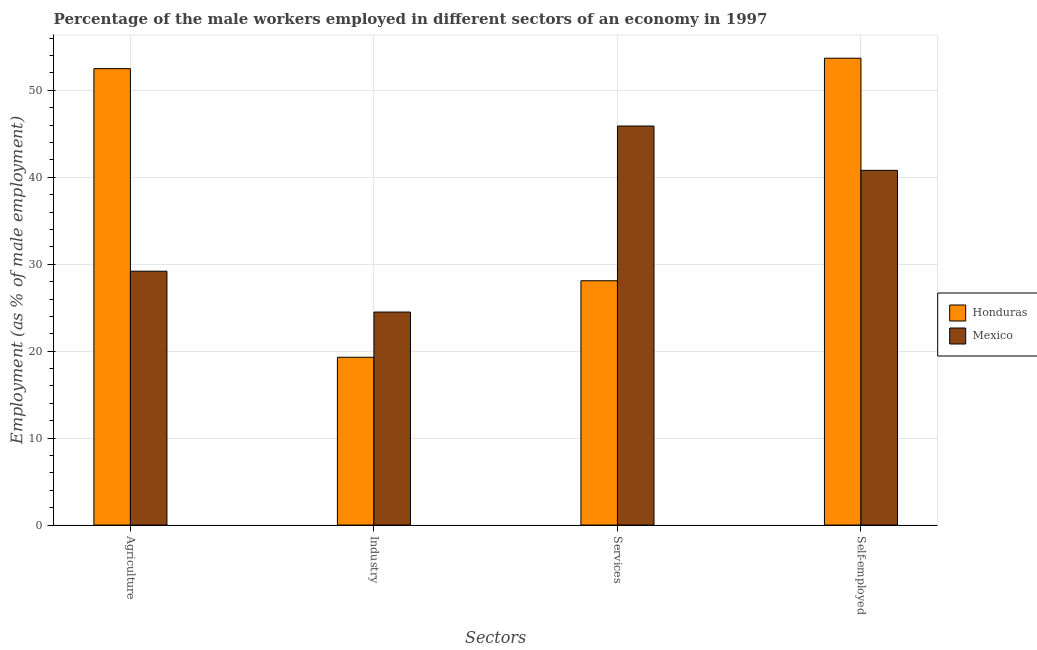How many bars are there on the 4th tick from the left?
Your answer should be very brief. 2. How many bars are there on the 1st tick from the right?
Provide a short and direct response. 2. What is the label of the 4th group of bars from the left?
Offer a very short reply. Self-employed. What is the percentage of male workers in agriculture in Mexico?
Provide a short and direct response. 29.2. Across all countries, what is the maximum percentage of male workers in services?
Provide a short and direct response. 45.9. Across all countries, what is the minimum percentage of male workers in agriculture?
Your answer should be compact. 29.2. In which country was the percentage of male workers in industry maximum?
Provide a succinct answer. Mexico. In which country was the percentage of male workers in industry minimum?
Offer a very short reply. Honduras. What is the total percentage of self employed male workers in the graph?
Give a very brief answer. 94.5. What is the difference between the percentage of male workers in agriculture in Mexico and that in Honduras?
Ensure brevity in your answer.  -23.3. What is the difference between the percentage of male workers in industry in Mexico and the percentage of self employed male workers in Honduras?
Provide a short and direct response. -29.2. What is the average percentage of male workers in services per country?
Your answer should be compact. 37. What is the difference between the percentage of male workers in agriculture and percentage of male workers in industry in Honduras?
Give a very brief answer. 33.2. In how many countries, is the percentage of male workers in services greater than 6 %?
Ensure brevity in your answer.  2. What is the ratio of the percentage of male workers in industry in Mexico to that in Honduras?
Keep it short and to the point. 1.27. Is the percentage of male workers in services in Honduras less than that in Mexico?
Give a very brief answer. Yes. What is the difference between the highest and the second highest percentage of male workers in services?
Your answer should be compact. 17.8. What is the difference between the highest and the lowest percentage of male workers in services?
Ensure brevity in your answer.  17.8. In how many countries, is the percentage of male workers in industry greater than the average percentage of male workers in industry taken over all countries?
Provide a succinct answer. 1. Is the sum of the percentage of male workers in services in Mexico and Honduras greater than the maximum percentage of male workers in agriculture across all countries?
Provide a succinct answer. Yes. What does the 2nd bar from the left in Services represents?
Offer a very short reply. Mexico. What does the 2nd bar from the right in Agriculture represents?
Provide a short and direct response. Honduras. How many bars are there?
Make the answer very short. 8. Does the graph contain any zero values?
Provide a short and direct response. No. Where does the legend appear in the graph?
Your answer should be very brief. Center right. What is the title of the graph?
Make the answer very short. Percentage of the male workers employed in different sectors of an economy in 1997. Does "Cambodia" appear as one of the legend labels in the graph?
Make the answer very short. No. What is the label or title of the X-axis?
Your answer should be very brief. Sectors. What is the label or title of the Y-axis?
Ensure brevity in your answer.  Employment (as % of male employment). What is the Employment (as % of male employment) in Honduras in Agriculture?
Your answer should be very brief. 52.5. What is the Employment (as % of male employment) of Mexico in Agriculture?
Give a very brief answer. 29.2. What is the Employment (as % of male employment) of Honduras in Industry?
Your answer should be compact. 19.3. What is the Employment (as % of male employment) of Honduras in Services?
Offer a terse response. 28.1. What is the Employment (as % of male employment) of Mexico in Services?
Give a very brief answer. 45.9. What is the Employment (as % of male employment) in Honduras in Self-employed?
Offer a very short reply. 53.7. What is the Employment (as % of male employment) in Mexico in Self-employed?
Offer a terse response. 40.8. Across all Sectors, what is the maximum Employment (as % of male employment) in Honduras?
Offer a very short reply. 53.7. Across all Sectors, what is the maximum Employment (as % of male employment) in Mexico?
Keep it short and to the point. 45.9. Across all Sectors, what is the minimum Employment (as % of male employment) in Honduras?
Provide a succinct answer. 19.3. What is the total Employment (as % of male employment) of Honduras in the graph?
Your answer should be very brief. 153.6. What is the total Employment (as % of male employment) in Mexico in the graph?
Your answer should be compact. 140.4. What is the difference between the Employment (as % of male employment) in Honduras in Agriculture and that in Industry?
Provide a succinct answer. 33.2. What is the difference between the Employment (as % of male employment) of Honduras in Agriculture and that in Services?
Ensure brevity in your answer.  24.4. What is the difference between the Employment (as % of male employment) of Mexico in Agriculture and that in Services?
Your answer should be very brief. -16.7. What is the difference between the Employment (as % of male employment) of Honduras in Agriculture and that in Self-employed?
Offer a terse response. -1.2. What is the difference between the Employment (as % of male employment) of Mexico in Agriculture and that in Self-employed?
Offer a terse response. -11.6. What is the difference between the Employment (as % of male employment) in Honduras in Industry and that in Services?
Your answer should be very brief. -8.8. What is the difference between the Employment (as % of male employment) of Mexico in Industry and that in Services?
Make the answer very short. -21.4. What is the difference between the Employment (as % of male employment) of Honduras in Industry and that in Self-employed?
Provide a short and direct response. -34.4. What is the difference between the Employment (as % of male employment) in Mexico in Industry and that in Self-employed?
Your answer should be very brief. -16.3. What is the difference between the Employment (as % of male employment) in Honduras in Services and that in Self-employed?
Give a very brief answer. -25.6. What is the difference between the Employment (as % of male employment) in Honduras in Agriculture and the Employment (as % of male employment) in Mexico in Industry?
Keep it short and to the point. 28. What is the difference between the Employment (as % of male employment) in Honduras in Agriculture and the Employment (as % of male employment) in Mexico in Self-employed?
Keep it short and to the point. 11.7. What is the difference between the Employment (as % of male employment) of Honduras in Industry and the Employment (as % of male employment) of Mexico in Services?
Ensure brevity in your answer.  -26.6. What is the difference between the Employment (as % of male employment) in Honduras in Industry and the Employment (as % of male employment) in Mexico in Self-employed?
Provide a short and direct response. -21.5. What is the difference between the Employment (as % of male employment) of Honduras in Services and the Employment (as % of male employment) of Mexico in Self-employed?
Your response must be concise. -12.7. What is the average Employment (as % of male employment) in Honduras per Sectors?
Give a very brief answer. 38.4. What is the average Employment (as % of male employment) in Mexico per Sectors?
Provide a short and direct response. 35.1. What is the difference between the Employment (as % of male employment) of Honduras and Employment (as % of male employment) of Mexico in Agriculture?
Give a very brief answer. 23.3. What is the difference between the Employment (as % of male employment) in Honduras and Employment (as % of male employment) in Mexico in Services?
Provide a short and direct response. -17.8. What is the ratio of the Employment (as % of male employment) in Honduras in Agriculture to that in Industry?
Provide a succinct answer. 2.72. What is the ratio of the Employment (as % of male employment) of Mexico in Agriculture to that in Industry?
Offer a very short reply. 1.19. What is the ratio of the Employment (as % of male employment) in Honduras in Agriculture to that in Services?
Your response must be concise. 1.87. What is the ratio of the Employment (as % of male employment) in Mexico in Agriculture to that in Services?
Give a very brief answer. 0.64. What is the ratio of the Employment (as % of male employment) in Honduras in Agriculture to that in Self-employed?
Your response must be concise. 0.98. What is the ratio of the Employment (as % of male employment) of Mexico in Agriculture to that in Self-employed?
Your response must be concise. 0.72. What is the ratio of the Employment (as % of male employment) in Honduras in Industry to that in Services?
Make the answer very short. 0.69. What is the ratio of the Employment (as % of male employment) in Mexico in Industry to that in Services?
Make the answer very short. 0.53. What is the ratio of the Employment (as % of male employment) in Honduras in Industry to that in Self-employed?
Offer a terse response. 0.36. What is the ratio of the Employment (as % of male employment) in Mexico in Industry to that in Self-employed?
Give a very brief answer. 0.6. What is the ratio of the Employment (as % of male employment) of Honduras in Services to that in Self-employed?
Your response must be concise. 0.52. What is the difference between the highest and the second highest Employment (as % of male employment) of Honduras?
Give a very brief answer. 1.2. What is the difference between the highest and the lowest Employment (as % of male employment) of Honduras?
Give a very brief answer. 34.4. What is the difference between the highest and the lowest Employment (as % of male employment) in Mexico?
Provide a succinct answer. 21.4. 